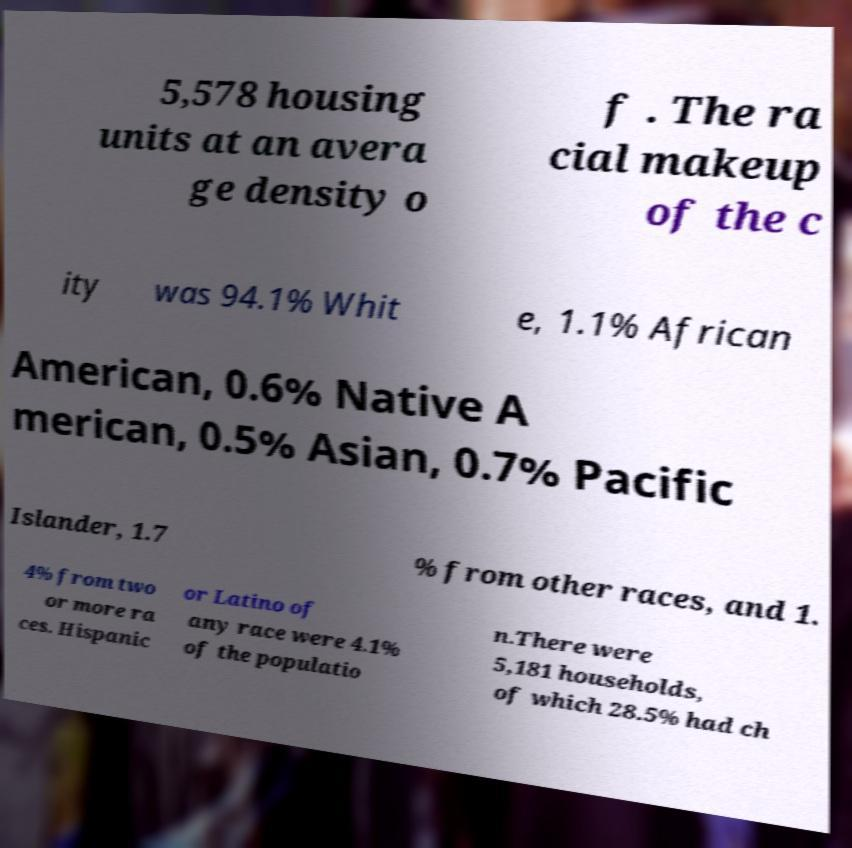What messages or text are displayed in this image? I need them in a readable, typed format. 5,578 housing units at an avera ge density o f . The ra cial makeup of the c ity was 94.1% Whit e, 1.1% African American, 0.6% Native A merican, 0.5% Asian, 0.7% Pacific Islander, 1.7 % from other races, and 1. 4% from two or more ra ces. Hispanic or Latino of any race were 4.1% of the populatio n.There were 5,181 households, of which 28.5% had ch 